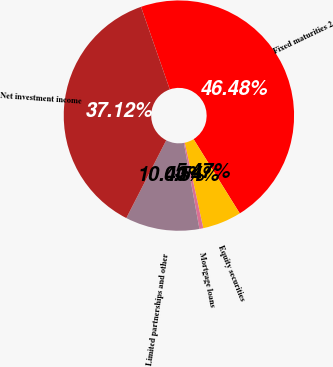<chart> <loc_0><loc_0><loc_500><loc_500><pie_chart><fcel>Fixed maturities 2<fcel>Equity securities<fcel>Mortgage loans<fcel>Limited partnerships and other<fcel>Net investment income<nl><fcel>46.48%<fcel>5.47%<fcel>0.54%<fcel>10.4%<fcel>37.12%<nl></chart> 